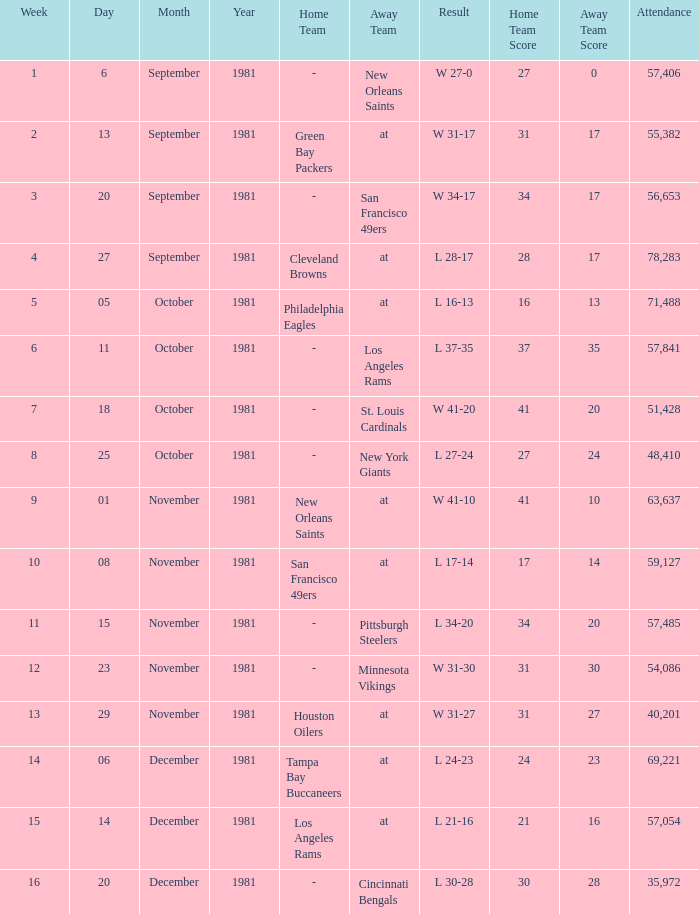What was the highest number of attendance in a week before 8 and game on October 25, 1981? None. Would you mind parsing the complete table? {'header': ['Week', 'Day', 'Month', 'Year', 'Home Team', 'Away Team', 'Result', 'Home Team Score', 'Away Team Score', 'Attendance'], 'rows': [['1', '6', 'September', '1981', '-', 'New Orleans Saints', 'W 27-0', '27', '0', '57,406'], ['2', '13', 'September', '1981', 'Green Bay Packers', 'at', 'W 31-17', '31', '17', '55,382'], ['3', '20', 'September', '1981', '-', 'San Francisco 49ers', 'W 34-17', '34', '17', '56,653'], ['4', '27', 'September', '1981', 'Cleveland Browns', 'at', 'L 28-17', '28', '17', '78,283'], ['5', '05', 'October', '1981', 'Philadelphia Eagles', 'at', 'L 16-13', '16', '13', '71,488'], ['6', '11', 'October', '1981', '-', 'Los Angeles Rams', 'L 37-35', '37', '35', '57,841'], ['7', '18', 'October', '1981', '-', 'St. Louis Cardinals', 'W 41-20', '41', '20', '51,428'], ['8', '25', 'October', '1981', '-', 'New York Giants', 'L 27-24', '27', '24', '48,410'], ['9', '01', 'November', '1981', 'New Orleans Saints', 'at', 'W 41-10', '41', '10', '63,637'], ['10', '08', 'November', '1981', 'San Francisco 49ers', 'at', 'L 17-14', '17', '14', '59,127'], ['11', '15', 'November', '1981', '-', 'Pittsburgh Steelers', 'L 34-20', '34', '20', '57,485'], ['12', '23', 'November', '1981', '-', 'Minnesota Vikings', 'W 31-30', '31', '30', '54,086'], ['13', '29', 'November', '1981', 'Houston Oilers', 'at', 'W 31-27', '31', '27', '40,201'], ['14', '06', 'December', '1981', 'Tampa Bay Buccaneers', 'at', 'L 24-23', '24', '23', '69,221'], ['15', '14', 'December', '1981', 'Los Angeles Rams', 'at', 'L 21-16', '21', '16', '57,054'], ['16', '20', 'December', '1981', '-', 'Cincinnati Bengals', 'L 30-28', '30', '28', '35,972']]} 